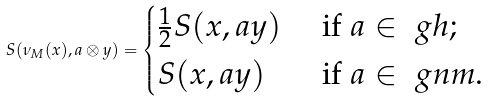<formula> <loc_0><loc_0><loc_500><loc_500>S ( \nu _ { M } ( x ) , a \otimes y ) = \begin{cases} \frac { 1 } { 2 } S ( x , a y ) & \text { if } a \in \ g h ; \\ S ( x , a y ) & \text { if } a \in \ g n m . \end{cases}</formula> 